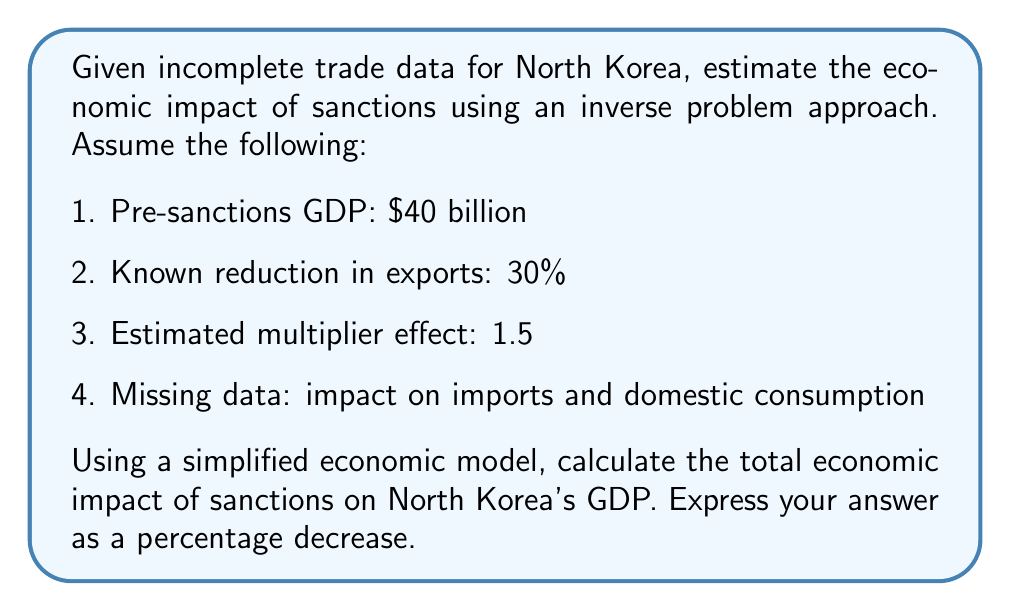Could you help me with this problem? To solve this inverse problem, we'll use the available data and make reasonable assumptions to estimate the missing information. Let's approach this step-by-step:

1. Start with the known reduction in exports:
   - 30% reduction in exports
   - Let's assume exports were 20% of GDP pre-sanctions
   - Impact of export reduction: $40 billion * 20% * 30% = $2.4 billion

2. Estimate the impact on imports:
   - Assume imports were also 20% of GDP pre-sanctions
   - Estimate a 25% reduction in imports (slightly less than exports due to essential goods)
   - Impact of import reduction: $40 billion * 20% * 25% = $2 billion

3. Estimate the impact on domestic consumption:
   - Assume domestic consumption was 60% of GDP pre-sanctions
   - Estimate a 10% reduction in domestic consumption due to economic hardship
   - Impact of consumption reduction: $40 billion * 60% * 10% = $2.4 billion

4. Calculate the direct impact:
   $$\text{Direct Impact} = 2.4 + 2 + 2.4 = 6.8 \text{ billion}$$

5. Apply the multiplier effect:
   $$\text{Total Impact} = 6.8 \text{ billion} * 1.5 = 10.2 \text{ billion}$$

6. Calculate the percentage decrease in GDP:
   $$\text{Percentage Decrease} = \frac{10.2 \text{ billion}}{40 \text{ billion}} * 100\% = 25.5\%$$

Therefore, the estimated economic impact of sanctions on North Korea's GDP is a 25.5% decrease.
Answer: 25.5% decrease in GDP 